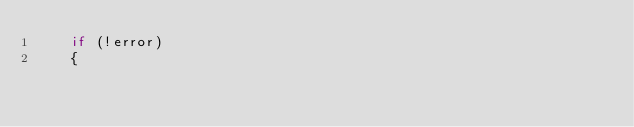<code> <loc_0><loc_0><loc_500><loc_500><_C++_>	if (!error)
	{</code> 